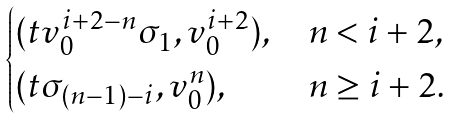Convert formula to latex. <formula><loc_0><loc_0><loc_500><loc_500>\begin{cases} ( t v _ { 0 } ^ { i + 2 - n } \sigma _ { 1 } , v _ { 0 } ^ { i + 2 } ) , & n < i + 2 , \\ ( t \sigma _ { ( n - 1 ) - i } , v _ { 0 } ^ { n } ) , & n \geq i + 2 . \end{cases}</formula> 